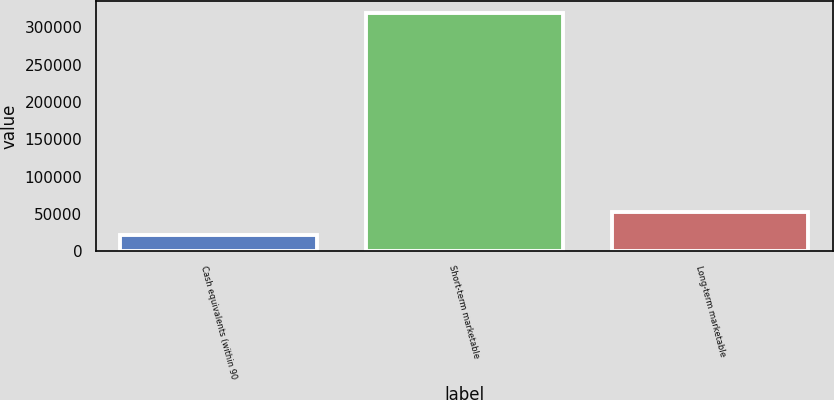<chart> <loc_0><loc_0><loc_500><loc_500><bar_chart><fcel>Cash equivalents (within 90<fcel>Short-term marketable<fcel>Long-term marketable<nl><fcel>22595<fcel>319274<fcel>52262.9<nl></chart> 